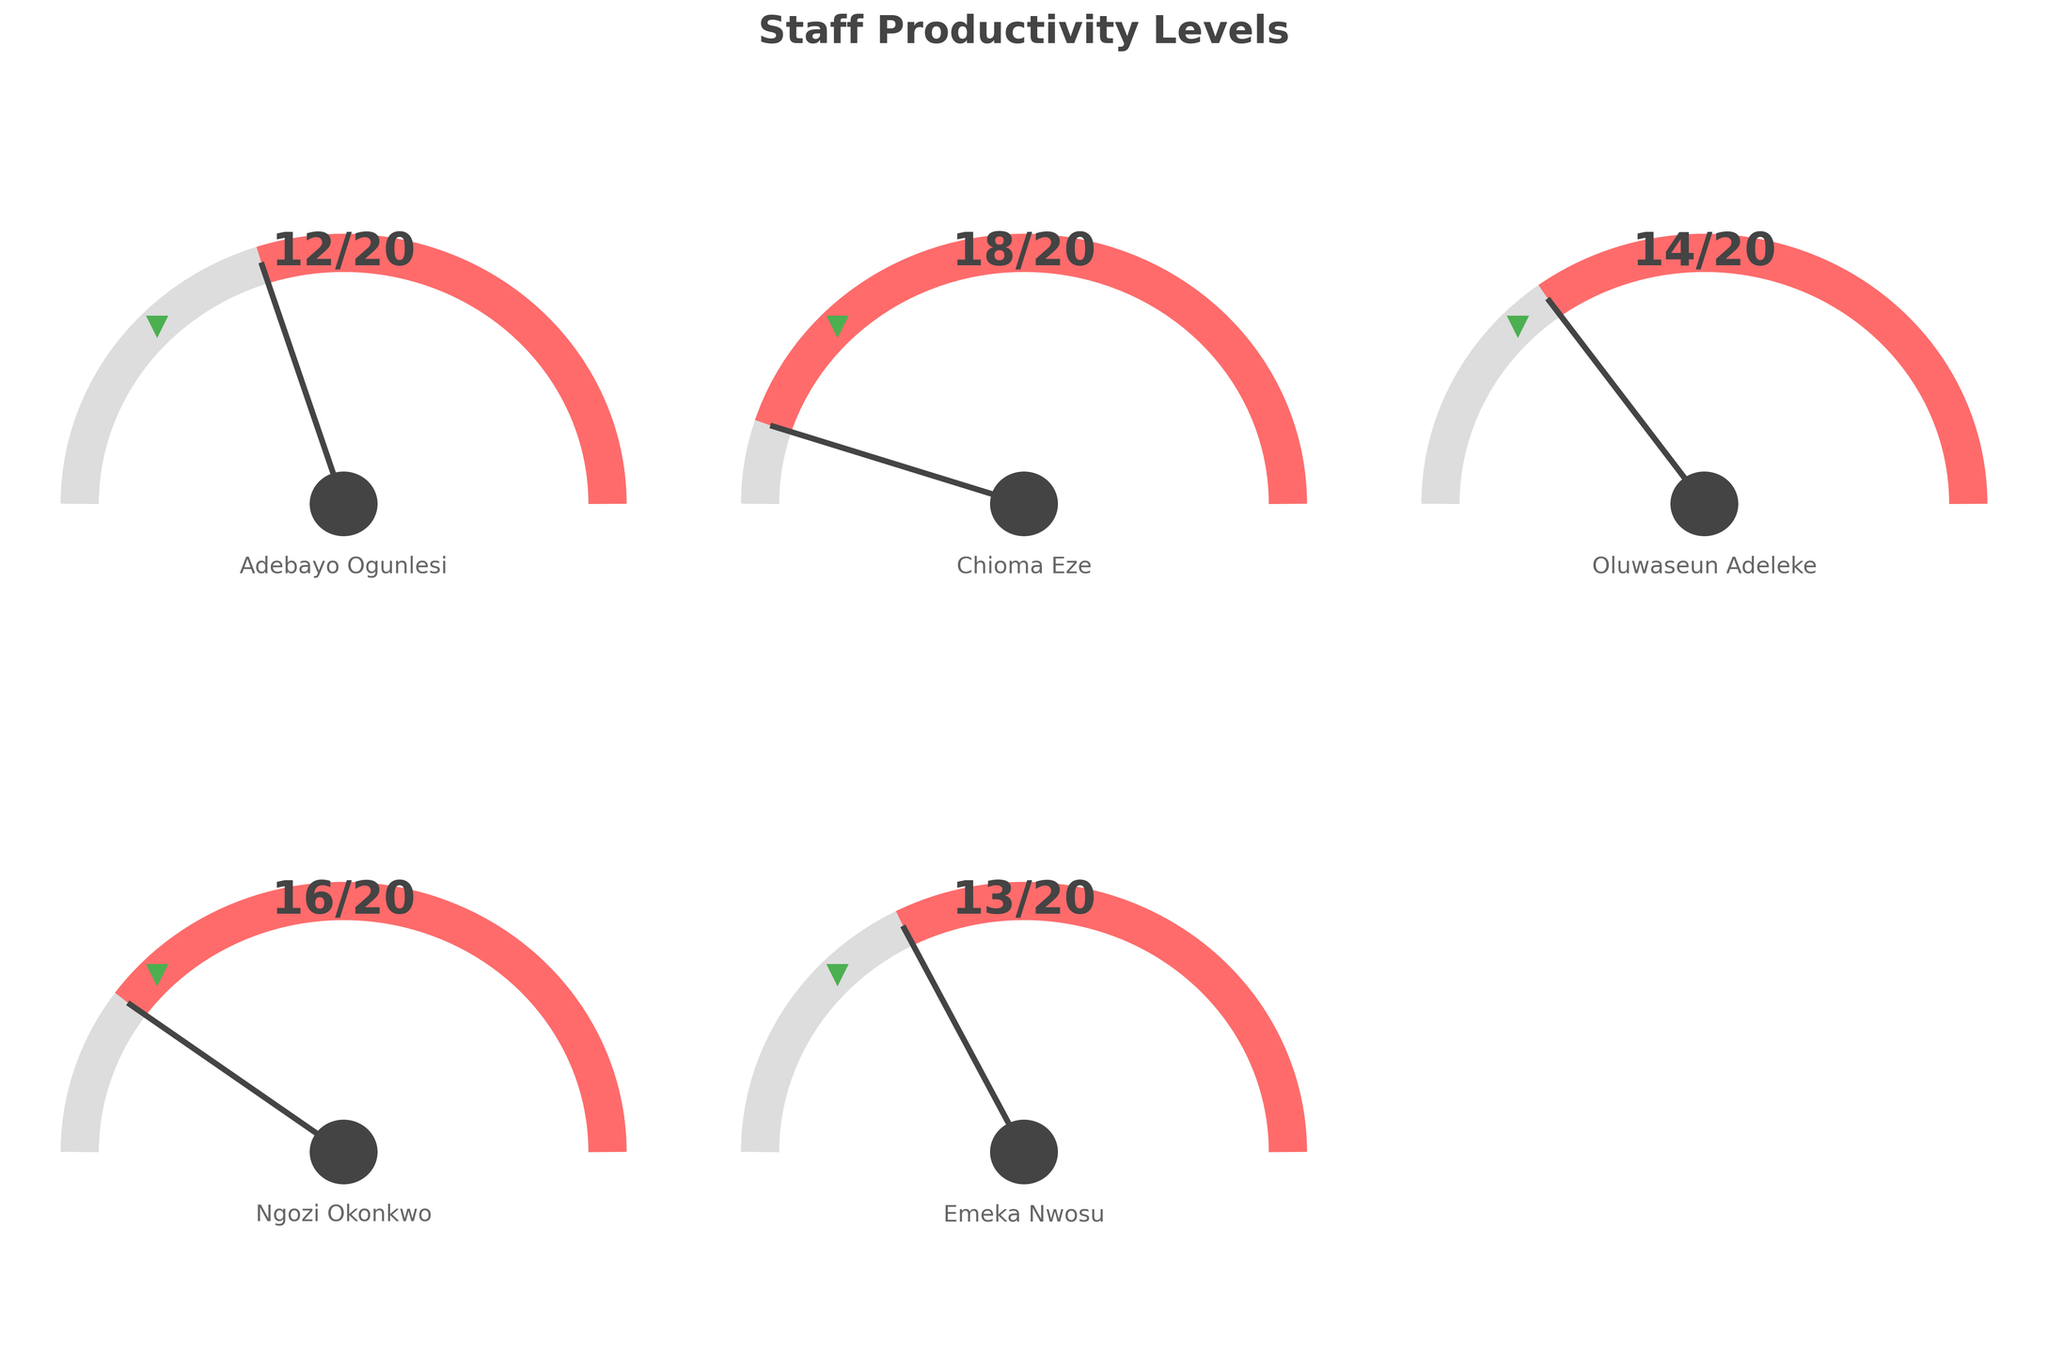What is the title of the figure? The title is always located at the top of the figure and usually describes the content of the figure.
Answer: Staff Productivity Levels How many employees are displayed on the figure? Each gauge chart represents one employee's weekly output. Based on the data, there are five employees visualized in the gauges.
Answer: Five Which employee has the highest weekly output? By examining the values displayed on each gauge chart, Chioma Eze has the highest output of 18 content pieces per week among the employees.
Answer: Chioma Eze Which employee's output is closest to the target? Compare the output level with the target level by observing the needle position relative to the green target marker for each employee. Ngozi Okonkwo's output of 16 is closest to the target of 15.
Answer: Ngozi Okonkwo What percentage of Chioma Eze's maximum output does her actual output represent? Chioma Eze's output is 18, and her maximum is 20. The percentage is calculated as (18/20) * 100 = 90%.
Answer: 90% Identify one employee who did not meet the target output level. Employees who did not meet their target will have the needle pointing below the green target marker. Adebayo Ogunlesi, with an output of 12, did not meet the target.
Answer: Adebayo Ogunlesi What is the combined content output of Adebayo Ogunlesi and Emeka Nwosu for a week? Add the output of Adebayo (12) and Emeka (13). Their combined output is 12 + 13.
Answer: 25 By how many content pieces did Oluwaseun Adeleke fall short of the target? Oluwaseun's output is 14, and the target is 15. The shortfall is calculated by subtracting 14 from 15.
Answer: 1 Which employee exceeds the target by the highest margin? Calculate the difference between the output and the target for each employee. Chioma Eze exceeds the target by 3 (18 - 15).
Answer: Chioma Eze What is the average weekly output of all employees? Sum the weekly outputs (12 + 18 + 14 + 16 + 13) and divide by the number of employees (5). The average is (12 + 18 + 14 + 16 + 13) / 5.
Answer: 14.6 